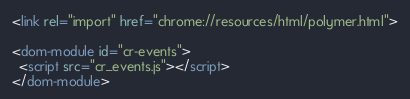Convert code to text. <code><loc_0><loc_0><loc_500><loc_500><_HTML_><link rel="import" href="chrome://resources/html/polymer.html">

<dom-module id="cr-events">
  <script src="cr_events.js"></script>
</dom-module>
</code> 